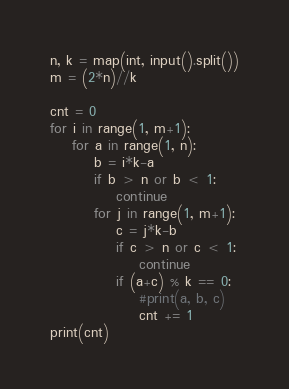Convert code to text. <code><loc_0><loc_0><loc_500><loc_500><_Python_>n, k = map(int, input().split())
m = (2*n)//k

cnt = 0
for i in range(1, m+1):
    for a in range(1, n):
        b = i*k-a
        if b > n or b < 1:
            continue
        for j in range(1, m+1):
            c = j*k-b
            if c > n or c < 1:
                continue
            if (a+c) % k == 0:
                #print(a, b, c)
                cnt += 1
print(cnt)
</code> 